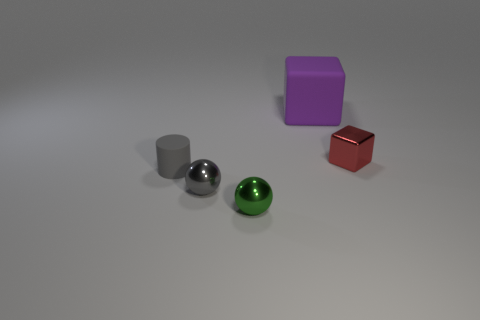Add 3 big cyan cylinders. How many objects exist? 8 Subtract all cylinders. How many objects are left? 4 Subtract 0 cyan cylinders. How many objects are left? 5 Subtract all tiny red shiny things. Subtract all blocks. How many objects are left? 2 Add 4 metallic spheres. How many metallic spheres are left? 6 Add 4 spheres. How many spheres exist? 6 